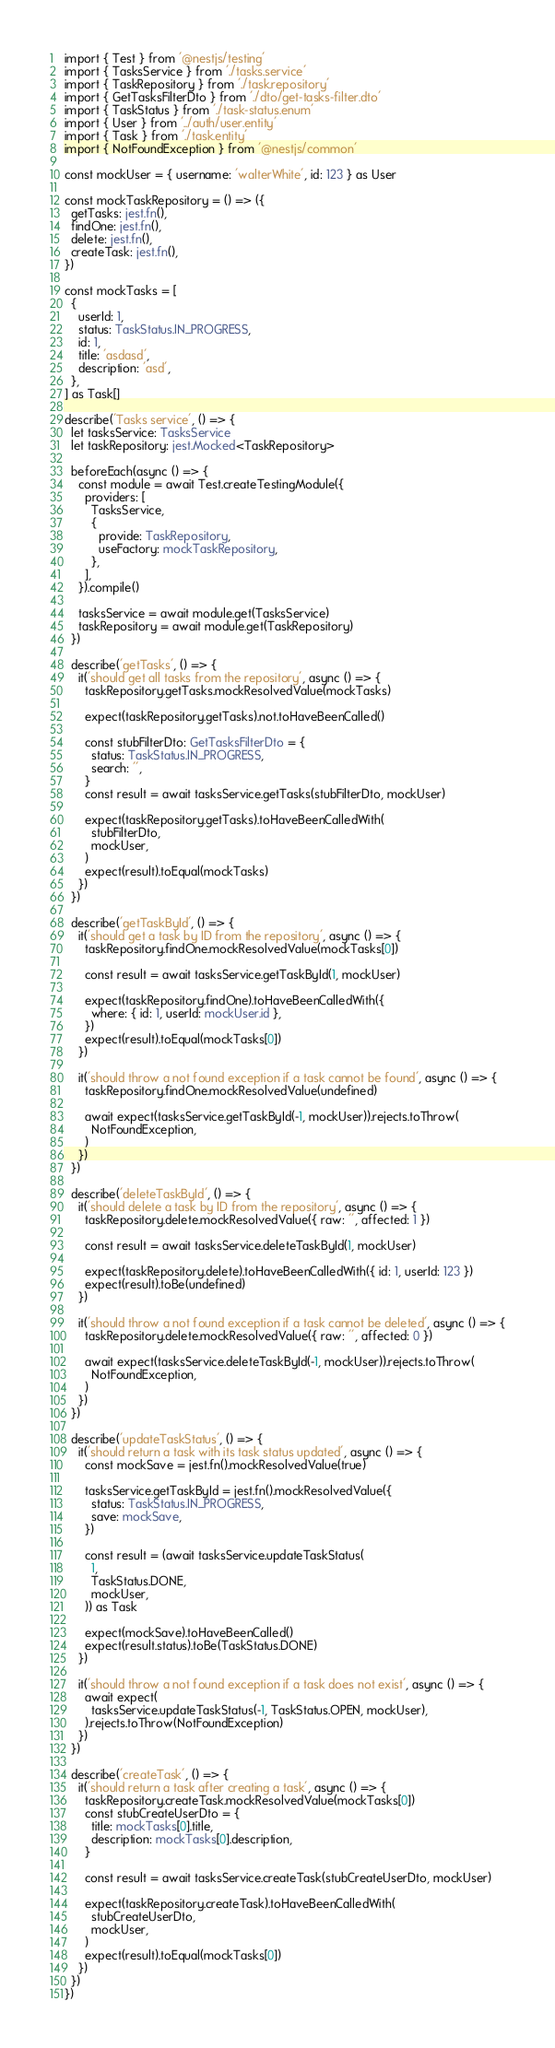<code> <loc_0><loc_0><loc_500><loc_500><_TypeScript_>import { Test } from '@nestjs/testing'
import { TasksService } from './tasks.service'
import { TaskRepository } from './task.repository'
import { GetTasksFilterDto } from './dto/get-tasks-filter.dto'
import { TaskStatus } from './task-status.enum'
import { User } from '../auth/user.entity'
import { Task } from './task.entity'
import { NotFoundException } from '@nestjs/common'

const mockUser = { username: 'walterWhite', id: 123 } as User

const mockTaskRepository = () => ({
  getTasks: jest.fn(),
  findOne: jest.fn(),
  delete: jest.fn(),
  createTask: jest.fn(),
})

const mockTasks = [
  {
    userId: 1,
    status: TaskStatus.IN_PROGRESS,
    id: 1,
    title: 'asdasd',
    description: 'asd',
  },
] as Task[]

describe('Tasks service', () => {
  let tasksService: TasksService
  let taskRepository: jest.Mocked<TaskRepository>

  beforeEach(async () => {
    const module = await Test.createTestingModule({
      providers: [
        TasksService,
        {
          provide: TaskRepository,
          useFactory: mockTaskRepository,
        },
      ],
    }).compile()

    tasksService = await module.get(TasksService)
    taskRepository = await module.get(TaskRepository)
  })

  describe('getTasks', () => {
    it('should get all tasks from the repository', async () => {
      taskRepository.getTasks.mockResolvedValue(mockTasks)

      expect(taskRepository.getTasks).not.toHaveBeenCalled()

      const stubFilterDto: GetTasksFilterDto = {
        status: TaskStatus.IN_PROGRESS,
        search: '',
      }
      const result = await tasksService.getTasks(stubFilterDto, mockUser)

      expect(taskRepository.getTasks).toHaveBeenCalledWith(
        stubFilterDto,
        mockUser,
      )
      expect(result).toEqual(mockTasks)
    })
  })

  describe('getTaskById', () => {
    it('should get a task by ID from the repository', async () => {
      taskRepository.findOne.mockResolvedValue(mockTasks[0])

      const result = await tasksService.getTaskById(1, mockUser)

      expect(taskRepository.findOne).toHaveBeenCalledWith({
        where: { id: 1, userId: mockUser.id },
      })
      expect(result).toEqual(mockTasks[0])
    })

    it('should throw a not found exception if a task cannot be found', async () => {
      taskRepository.findOne.mockResolvedValue(undefined)

      await expect(tasksService.getTaskById(-1, mockUser)).rejects.toThrow(
        NotFoundException,
      )
    })
  })

  describe('deleteTaskById', () => {
    it('should delete a task by ID from the repository', async () => {
      taskRepository.delete.mockResolvedValue({ raw: '', affected: 1 })

      const result = await tasksService.deleteTaskById(1, mockUser)

      expect(taskRepository.delete).toHaveBeenCalledWith({ id: 1, userId: 123 })
      expect(result).toBe(undefined)
    })

    it('should throw a not found exception if a task cannot be deleted', async () => {
      taskRepository.delete.mockResolvedValue({ raw: '', affected: 0 })

      await expect(tasksService.deleteTaskById(-1, mockUser)).rejects.toThrow(
        NotFoundException,
      )
    })
  })

  describe('updateTaskStatus', () => {
    it('should return a task with its task status updated', async () => {
      const mockSave = jest.fn().mockResolvedValue(true)

      tasksService.getTaskById = jest.fn().mockResolvedValue({
        status: TaskStatus.IN_PROGRESS,
        save: mockSave,
      })

      const result = (await tasksService.updateTaskStatus(
        1,
        TaskStatus.DONE,
        mockUser,
      )) as Task

      expect(mockSave).toHaveBeenCalled()
      expect(result.status).toBe(TaskStatus.DONE)
    })

    it('should throw a not found exception if a task does not exist', async () => {
      await expect(
        tasksService.updateTaskStatus(-1, TaskStatus.OPEN, mockUser),
      ).rejects.toThrow(NotFoundException)
    })
  })

  describe('createTask', () => {
    it('should return a task after creating a task', async () => {
      taskRepository.createTask.mockResolvedValue(mockTasks[0])
      const stubCreateUserDto = {
        title: mockTasks[0].title,
        description: mockTasks[0].description,
      }

      const result = await tasksService.createTask(stubCreateUserDto, mockUser)

      expect(taskRepository.createTask).toHaveBeenCalledWith(
        stubCreateUserDto,
        mockUser,
      )
      expect(result).toEqual(mockTasks[0])
    })
  })
})
</code> 